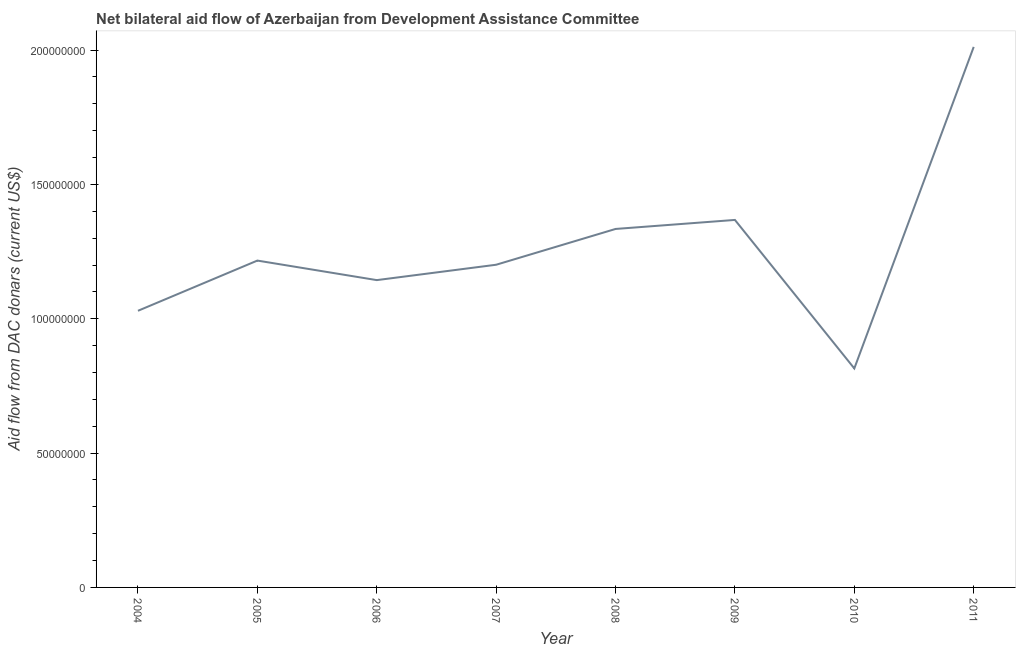What is the net bilateral aid flows from dac donors in 2005?
Offer a very short reply. 1.22e+08. Across all years, what is the maximum net bilateral aid flows from dac donors?
Provide a short and direct response. 2.01e+08. Across all years, what is the minimum net bilateral aid flows from dac donors?
Give a very brief answer. 8.15e+07. In which year was the net bilateral aid flows from dac donors maximum?
Provide a short and direct response. 2011. What is the sum of the net bilateral aid flows from dac donors?
Your response must be concise. 1.01e+09. What is the difference between the net bilateral aid flows from dac donors in 2007 and 2011?
Ensure brevity in your answer.  -8.11e+07. What is the average net bilateral aid flows from dac donors per year?
Offer a very short reply. 1.26e+08. What is the median net bilateral aid flows from dac donors?
Offer a very short reply. 1.21e+08. What is the ratio of the net bilateral aid flows from dac donors in 2004 to that in 2009?
Offer a terse response. 0.75. Is the difference between the net bilateral aid flows from dac donors in 2006 and 2007 greater than the difference between any two years?
Keep it short and to the point. No. What is the difference between the highest and the second highest net bilateral aid flows from dac donors?
Your response must be concise. 6.44e+07. Is the sum of the net bilateral aid flows from dac donors in 2009 and 2010 greater than the maximum net bilateral aid flows from dac donors across all years?
Give a very brief answer. Yes. What is the difference between the highest and the lowest net bilateral aid flows from dac donors?
Ensure brevity in your answer.  1.20e+08. In how many years, is the net bilateral aid flows from dac donors greater than the average net bilateral aid flows from dac donors taken over all years?
Your answer should be compact. 3. How many lines are there?
Your answer should be very brief. 1. How many years are there in the graph?
Give a very brief answer. 8. What is the difference between two consecutive major ticks on the Y-axis?
Your response must be concise. 5.00e+07. What is the title of the graph?
Offer a very short reply. Net bilateral aid flow of Azerbaijan from Development Assistance Committee. What is the label or title of the Y-axis?
Your response must be concise. Aid flow from DAC donars (current US$). What is the Aid flow from DAC donars (current US$) of 2004?
Your response must be concise. 1.03e+08. What is the Aid flow from DAC donars (current US$) of 2005?
Offer a very short reply. 1.22e+08. What is the Aid flow from DAC donars (current US$) of 2006?
Your answer should be very brief. 1.14e+08. What is the Aid flow from DAC donars (current US$) in 2007?
Ensure brevity in your answer.  1.20e+08. What is the Aid flow from DAC donars (current US$) of 2008?
Keep it short and to the point. 1.33e+08. What is the Aid flow from DAC donars (current US$) in 2009?
Give a very brief answer. 1.37e+08. What is the Aid flow from DAC donars (current US$) of 2010?
Provide a succinct answer. 8.15e+07. What is the Aid flow from DAC donars (current US$) in 2011?
Provide a succinct answer. 2.01e+08. What is the difference between the Aid flow from DAC donars (current US$) in 2004 and 2005?
Provide a short and direct response. -1.87e+07. What is the difference between the Aid flow from DAC donars (current US$) in 2004 and 2006?
Your answer should be compact. -1.14e+07. What is the difference between the Aid flow from DAC donars (current US$) in 2004 and 2007?
Ensure brevity in your answer.  -1.71e+07. What is the difference between the Aid flow from DAC donars (current US$) in 2004 and 2008?
Keep it short and to the point. -3.05e+07. What is the difference between the Aid flow from DAC donars (current US$) in 2004 and 2009?
Ensure brevity in your answer.  -3.38e+07. What is the difference between the Aid flow from DAC donars (current US$) in 2004 and 2010?
Offer a terse response. 2.15e+07. What is the difference between the Aid flow from DAC donars (current US$) in 2004 and 2011?
Keep it short and to the point. -9.82e+07. What is the difference between the Aid flow from DAC donars (current US$) in 2005 and 2006?
Give a very brief answer. 7.27e+06. What is the difference between the Aid flow from DAC donars (current US$) in 2005 and 2007?
Make the answer very short. 1.55e+06. What is the difference between the Aid flow from DAC donars (current US$) in 2005 and 2008?
Your response must be concise. -1.18e+07. What is the difference between the Aid flow from DAC donars (current US$) in 2005 and 2009?
Your response must be concise. -1.51e+07. What is the difference between the Aid flow from DAC donars (current US$) in 2005 and 2010?
Your answer should be compact. 4.02e+07. What is the difference between the Aid flow from DAC donars (current US$) in 2005 and 2011?
Keep it short and to the point. -7.95e+07. What is the difference between the Aid flow from DAC donars (current US$) in 2006 and 2007?
Provide a short and direct response. -5.72e+06. What is the difference between the Aid flow from DAC donars (current US$) in 2006 and 2008?
Make the answer very short. -1.90e+07. What is the difference between the Aid flow from DAC donars (current US$) in 2006 and 2009?
Your response must be concise. -2.24e+07. What is the difference between the Aid flow from DAC donars (current US$) in 2006 and 2010?
Offer a very short reply. 3.29e+07. What is the difference between the Aid flow from DAC donars (current US$) in 2006 and 2011?
Ensure brevity in your answer.  -8.68e+07. What is the difference between the Aid flow from DAC donars (current US$) in 2007 and 2008?
Your answer should be very brief. -1.33e+07. What is the difference between the Aid flow from DAC donars (current US$) in 2007 and 2009?
Keep it short and to the point. -1.67e+07. What is the difference between the Aid flow from DAC donars (current US$) in 2007 and 2010?
Ensure brevity in your answer.  3.86e+07. What is the difference between the Aid flow from DAC donars (current US$) in 2007 and 2011?
Make the answer very short. -8.11e+07. What is the difference between the Aid flow from DAC donars (current US$) in 2008 and 2009?
Give a very brief answer. -3.36e+06. What is the difference between the Aid flow from DAC donars (current US$) in 2008 and 2010?
Provide a short and direct response. 5.19e+07. What is the difference between the Aid flow from DAC donars (current US$) in 2008 and 2011?
Offer a very short reply. -6.78e+07. What is the difference between the Aid flow from DAC donars (current US$) in 2009 and 2010?
Your answer should be compact. 5.53e+07. What is the difference between the Aid flow from DAC donars (current US$) in 2009 and 2011?
Ensure brevity in your answer.  -6.44e+07. What is the difference between the Aid flow from DAC donars (current US$) in 2010 and 2011?
Your response must be concise. -1.20e+08. What is the ratio of the Aid flow from DAC donars (current US$) in 2004 to that in 2005?
Ensure brevity in your answer.  0.85. What is the ratio of the Aid flow from DAC donars (current US$) in 2004 to that in 2007?
Make the answer very short. 0.86. What is the ratio of the Aid flow from DAC donars (current US$) in 2004 to that in 2008?
Keep it short and to the point. 0.77. What is the ratio of the Aid flow from DAC donars (current US$) in 2004 to that in 2009?
Keep it short and to the point. 0.75. What is the ratio of the Aid flow from DAC donars (current US$) in 2004 to that in 2010?
Offer a terse response. 1.26. What is the ratio of the Aid flow from DAC donars (current US$) in 2004 to that in 2011?
Provide a short and direct response. 0.51. What is the ratio of the Aid flow from DAC donars (current US$) in 2005 to that in 2006?
Ensure brevity in your answer.  1.06. What is the ratio of the Aid flow from DAC donars (current US$) in 2005 to that in 2008?
Offer a very short reply. 0.91. What is the ratio of the Aid flow from DAC donars (current US$) in 2005 to that in 2009?
Keep it short and to the point. 0.89. What is the ratio of the Aid flow from DAC donars (current US$) in 2005 to that in 2010?
Make the answer very short. 1.49. What is the ratio of the Aid flow from DAC donars (current US$) in 2005 to that in 2011?
Provide a short and direct response. 0.6. What is the ratio of the Aid flow from DAC donars (current US$) in 2006 to that in 2007?
Provide a short and direct response. 0.95. What is the ratio of the Aid flow from DAC donars (current US$) in 2006 to that in 2008?
Your answer should be very brief. 0.86. What is the ratio of the Aid flow from DAC donars (current US$) in 2006 to that in 2009?
Ensure brevity in your answer.  0.84. What is the ratio of the Aid flow from DAC donars (current US$) in 2006 to that in 2010?
Make the answer very short. 1.4. What is the ratio of the Aid flow from DAC donars (current US$) in 2006 to that in 2011?
Offer a terse response. 0.57. What is the ratio of the Aid flow from DAC donars (current US$) in 2007 to that in 2009?
Give a very brief answer. 0.88. What is the ratio of the Aid flow from DAC donars (current US$) in 2007 to that in 2010?
Make the answer very short. 1.47. What is the ratio of the Aid flow from DAC donars (current US$) in 2007 to that in 2011?
Your answer should be very brief. 0.6. What is the ratio of the Aid flow from DAC donars (current US$) in 2008 to that in 2010?
Provide a succinct answer. 1.64. What is the ratio of the Aid flow from DAC donars (current US$) in 2008 to that in 2011?
Offer a very short reply. 0.66. What is the ratio of the Aid flow from DAC donars (current US$) in 2009 to that in 2010?
Give a very brief answer. 1.68. What is the ratio of the Aid flow from DAC donars (current US$) in 2009 to that in 2011?
Provide a succinct answer. 0.68. What is the ratio of the Aid flow from DAC donars (current US$) in 2010 to that in 2011?
Give a very brief answer. 0.41. 